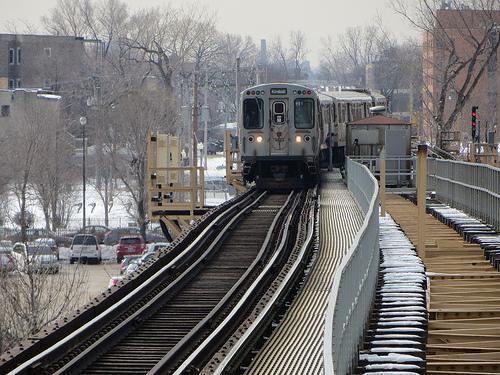How many trains are visible?
Give a very brief answer. 1. 